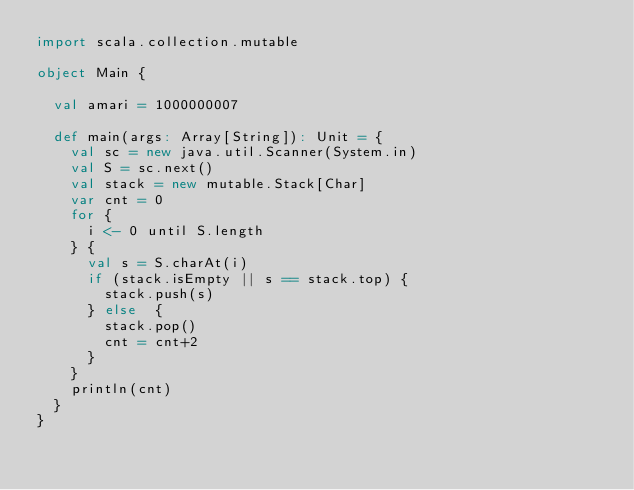Convert code to text. <code><loc_0><loc_0><loc_500><loc_500><_Scala_>import scala.collection.mutable

object Main {

  val amari = 1000000007

  def main(args: Array[String]): Unit = {
    val sc = new java.util.Scanner(System.in)
    val S = sc.next()
    val stack = new mutable.Stack[Char]
    var cnt = 0
    for {
      i <- 0 until S.length
    } {
      val s = S.charAt(i)
      if (stack.isEmpty || s == stack.top) {
        stack.push(s)
      } else  {
        stack.pop()
        cnt = cnt+2
      }
    }
    println(cnt)
  }
}
</code> 